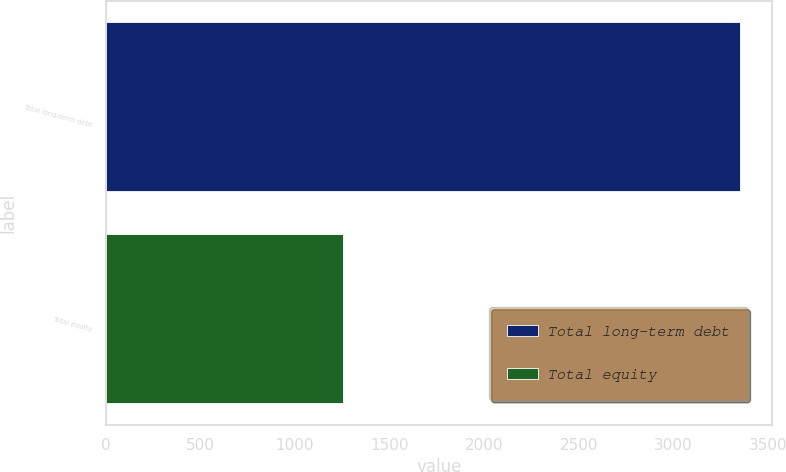Convert chart to OTSL. <chart><loc_0><loc_0><loc_500><loc_500><bar_chart><fcel>Total long-term debt<fcel>Total equity<nl><fcel>3353.6<fcel>1254.3<nl></chart> 